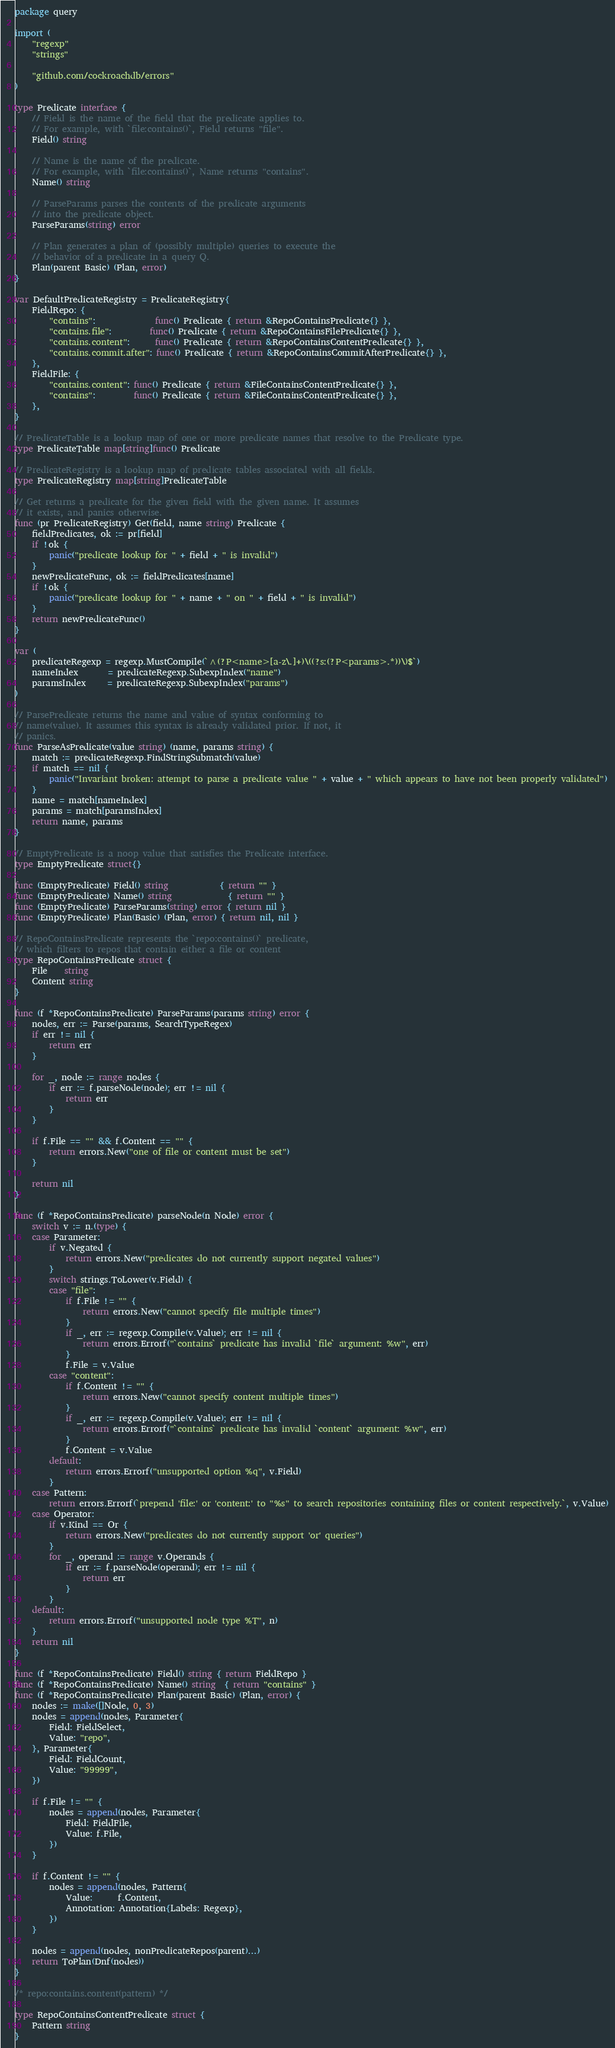<code> <loc_0><loc_0><loc_500><loc_500><_Go_>package query

import (
	"regexp"
	"strings"

	"github.com/cockroachdb/errors"
)

type Predicate interface {
	// Field is the name of the field that the predicate applies to.
	// For example, with `file:contains()`, Field returns "file".
	Field() string

	// Name is the name of the predicate.
	// For example, with `file:contains()`, Name returns "contains".
	Name() string

	// ParseParams parses the contents of the predicate arguments
	// into the predicate object.
	ParseParams(string) error

	// Plan generates a plan of (possibly multiple) queries to execute the
	// behavior of a predicate in a query Q.
	Plan(parent Basic) (Plan, error)
}

var DefaultPredicateRegistry = PredicateRegistry{
	FieldRepo: {
		"contains":              func() Predicate { return &RepoContainsPredicate{} },
		"contains.file":         func() Predicate { return &RepoContainsFilePredicate{} },
		"contains.content":      func() Predicate { return &RepoContainsContentPredicate{} },
		"contains.commit.after": func() Predicate { return &RepoContainsCommitAfterPredicate{} },
	},
	FieldFile: {
		"contains.content": func() Predicate { return &FileContainsContentPredicate{} },
		"contains":         func() Predicate { return &FileContainsContentPredicate{} },
	},
}

// PredicateTable is a lookup map of one or more predicate names that resolve to the Predicate type.
type PredicateTable map[string]func() Predicate

// PredicateRegistry is a lookup map of predicate tables associated with all fields.
type PredicateRegistry map[string]PredicateTable

// Get returns a predicate for the given field with the given name. It assumes
// it exists, and panics otherwise.
func (pr PredicateRegistry) Get(field, name string) Predicate {
	fieldPredicates, ok := pr[field]
	if !ok {
		panic("predicate lookup for " + field + " is invalid")
	}
	newPredicateFunc, ok := fieldPredicates[name]
	if !ok {
		panic("predicate lookup for " + name + " on " + field + " is invalid")
	}
	return newPredicateFunc()
}

var (
	predicateRegexp = regexp.MustCompile(`^(?P<name>[a-z\.]+)\((?s:(?P<params>.*))\)$`)
	nameIndex       = predicateRegexp.SubexpIndex("name")
	paramsIndex     = predicateRegexp.SubexpIndex("params")
)

// ParsePredicate returns the name and value of syntax conforming to
// name(value). It assumes this syntax is already validated prior. If not, it
// panics.
func ParseAsPredicate(value string) (name, params string) {
	match := predicateRegexp.FindStringSubmatch(value)
	if match == nil {
		panic("Invariant broken: attempt to parse a predicate value " + value + " which appears to have not been properly validated")
	}
	name = match[nameIndex]
	params = match[paramsIndex]
	return name, params
}

// EmptyPredicate is a noop value that satisfies the Predicate interface.
type EmptyPredicate struct{}

func (EmptyPredicate) Field() string            { return "" }
func (EmptyPredicate) Name() string             { return "" }
func (EmptyPredicate) ParseParams(string) error { return nil }
func (EmptyPredicate) Plan(Basic) (Plan, error) { return nil, nil }

// RepoContainsPredicate represents the `repo:contains()` predicate,
// which filters to repos that contain either a file or content
type RepoContainsPredicate struct {
	File    string
	Content string
}

func (f *RepoContainsPredicate) ParseParams(params string) error {
	nodes, err := Parse(params, SearchTypeRegex)
	if err != nil {
		return err
	}

	for _, node := range nodes {
		if err := f.parseNode(node); err != nil {
			return err
		}
	}

	if f.File == "" && f.Content == "" {
		return errors.New("one of file or content must be set")
	}

	return nil
}

func (f *RepoContainsPredicate) parseNode(n Node) error {
	switch v := n.(type) {
	case Parameter:
		if v.Negated {
			return errors.New("predicates do not currently support negated values")
		}
		switch strings.ToLower(v.Field) {
		case "file":
			if f.File != "" {
				return errors.New("cannot specify file multiple times")
			}
			if _, err := regexp.Compile(v.Value); err != nil {
				return errors.Errorf("`contains` predicate has invalid `file` argument: %w", err)
			}
			f.File = v.Value
		case "content":
			if f.Content != "" {
				return errors.New("cannot specify content multiple times")
			}
			if _, err := regexp.Compile(v.Value); err != nil {
				return errors.Errorf("`contains` predicate has invalid `content` argument: %w", err)
			}
			f.Content = v.Value
		default:
			return errors.Errorf("unsupported option %q", v.Field)
		}
	case Pattern:
		return errors.Errorf(`prepend 'file:' or 'content:' to "%s" to search repositories containing files or content respectively.`, v.Value)
	case Operator:
		if v.Kind == Or {
			return errors.New("predicates do not currently support 'or' queries")
		}
		for _, operand := range v.Operands {
			if err := f.parseNode(operand); err != nil {
				return err
			}
		}
	default:
		return errors.Errorf("unsupported node type %T", n)
	}
	return nil
}

func (f *RepoContainsPredicate) Field() string { return FieldRepo }
func (f *RepoContainsPredicate) Name() string  { return "contains" }
func (f *RepoContainsPredicate) Plan(parent Basic) (Plan, error) {
	nodes := make([]Node, 0, 3)
	nodes = append(nodes, Parameter{
		Field: FieldSelect,
		Value: "repo",
	}, Parameter{
		Field: FieldCount,
		Value: "99999",
	})

	if f.File != "" {
		nodes = append(nodes, Parameter{
			Field: FieldFile,
			Value: f.File,
		})
	}

	if f.Content != "" {
		nodes = append(nodes, Pattern{
			Value:      f.Content,
			Annotation: Annotation{Labels: Regexp},
		})
	}

	nodes = append(nodes, nonPredicateRepos(parent)...)
	return ToPlan(Dnf(nodes))
}

/* repo:contains.content(pattern) */

type RepoContainsContentPredicate struct {
	Pattern string
}
</code> 